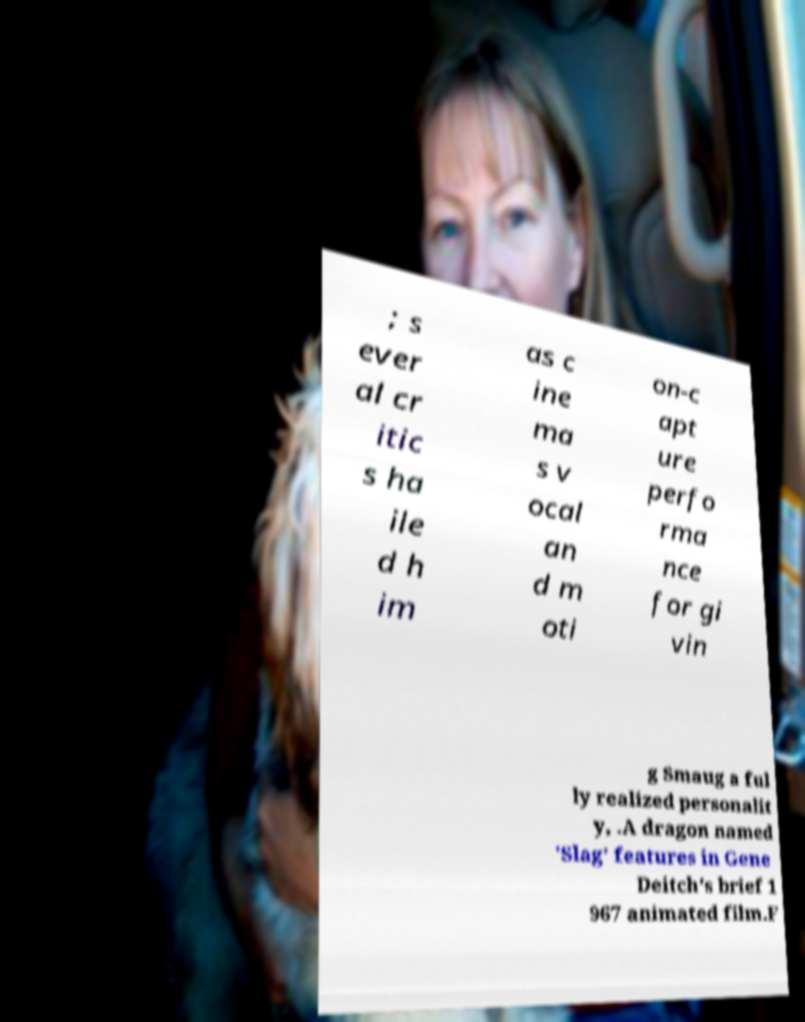There's text embedded in this image that I need extracted. Can you transcribe it verbatim? ; s ever al cr itic s ha ile d h im as c ine ma s v ocal an d m oti on-c apt ure perfo rma nce for gi vin g Smaug a ful ly realized personalit y, .A dragon named 'Slag' features in Gene Deitch's brief 1 967 animated film.F 